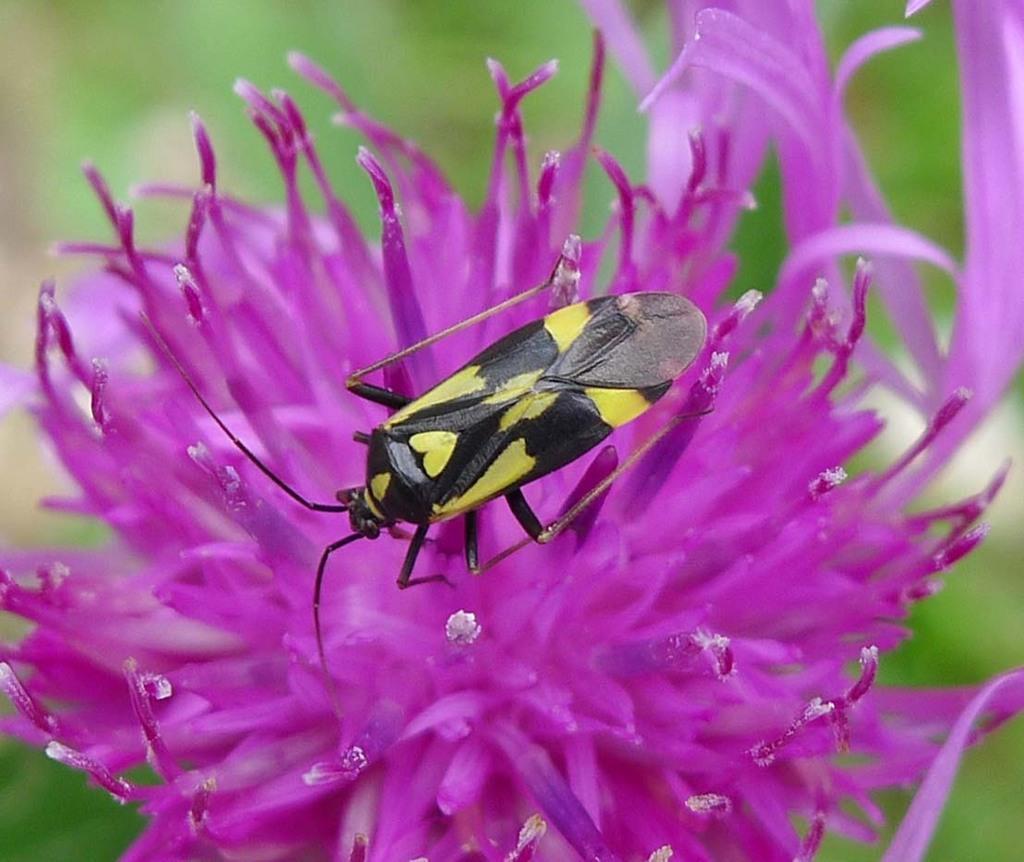How would you summarize this image in a sentence or two? In this picture we can see an insect on a purple flower and behind the flower there is a blurred background. 